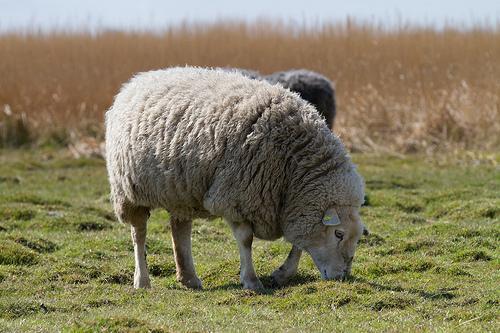How many animals are there?
Give a very brief answer. 2. 